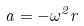<formula> <loc_0><loc_0><loc_500><loc_500>a = - \omega ^ { 2 } r</formula> 